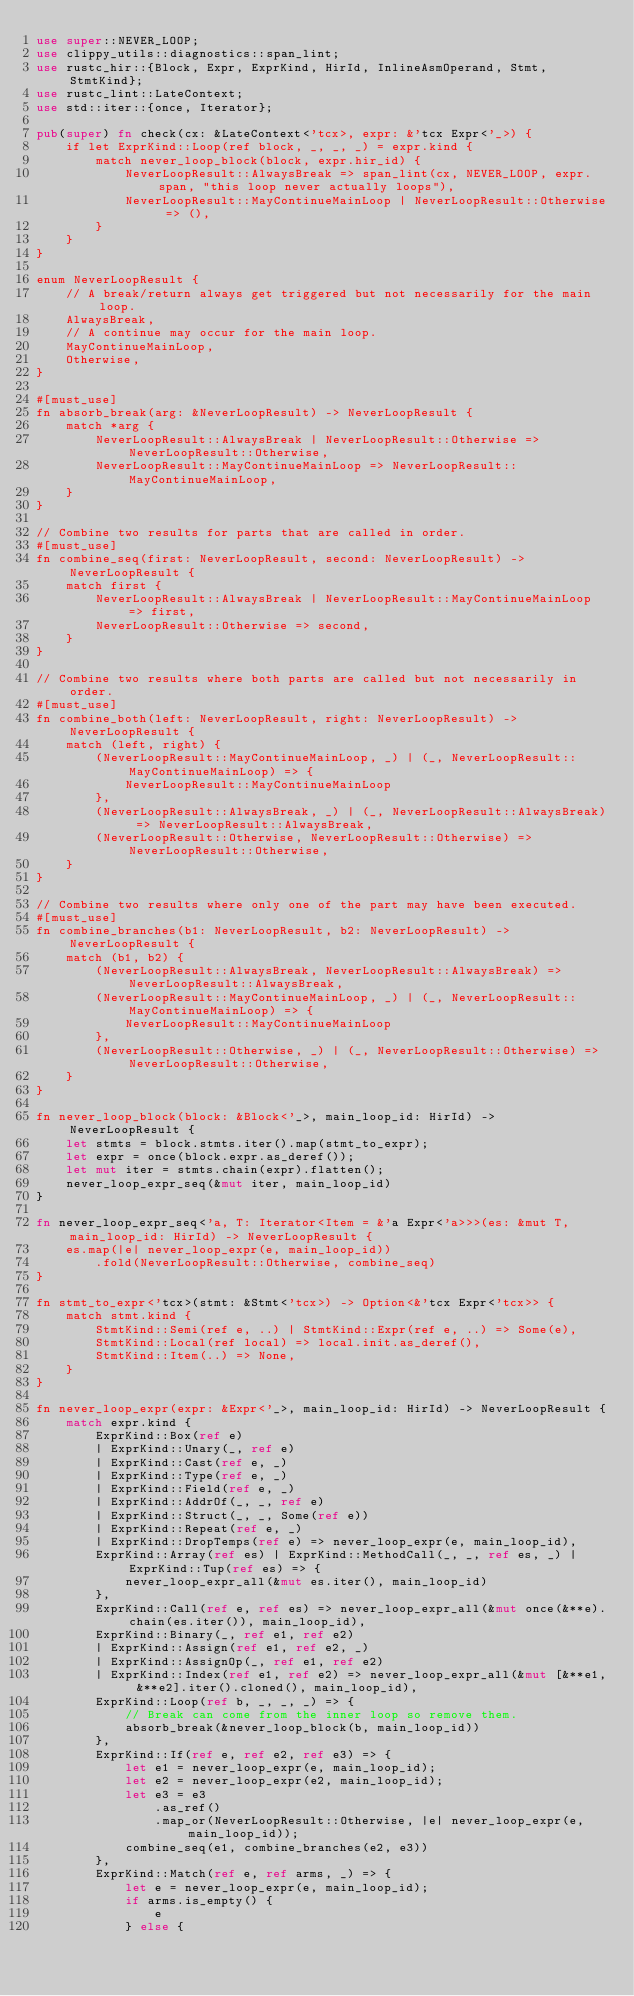Convert code to text. <code><loc_0><loc_0><loc_500><loc_500><_Rust_>use super::NEVER_LOOP;
use clippy_utils::diagnostics::span_lint;
use rustc_hir::{Block, Expr, ExprKind, HirId, InlineAsmOperand, Stmt, StmtKind};
use rustc_lint::LateContext;
use std::iter::{once, Iterator};

pub(super) fn check(cx: &LateContext<'tcx>, expr: &'tcx Expr<'_>) {
    if let ExprKind::Loop(ref block, _, _, _) = expr.kind {
        match never_loop_block(block, expr.hir_id) {
            NeverLoopResult::AlwaysBreak => span_lint(cx, NEVER_LOOP, expr.span, "this loop never actually loops"),
            NeverLoopResult::MayContinueMainLoop | NeverLoopResult::Otherwise => (),
        }
    }
}

enum NeverLoopResult {
    // A break/return always get triggered but not necessarily for the main loop.
    AlwaysBreak,
    // A continue may occur for the main loop.
    MayContinueMainLoop,
    Otherwise,
}

#[must_use]
fn absorb_break(arg: &NeverLoopResult) -> NeverLoopResult {
    match *arg {
        NeverLoopResult::AlwaysBreak | NeverLoopResult::Otherwise => NeverLoopResult::Otherwise,
        NeverLoopResult::MayContinueMainLoop => NeverLoopResult::MayContinueMainLoop,
    }
}

// Combine two results for parts that are called in order.
#[must_use]
fn combine_seq(first: NeverLoopResult, second: NeverLoopResult) -> NeverLoopResult {
    match first {
        NeverLoopResult::AlwaysBreak | NeverLoopResult::MayContinueMainLoop => first,
        NeverLoopResult::Otherwise => second,
    }
}

// Combine two results where both parts are called but not necessarily in order.
#[must_use]
fn combine_both(left: NeverLoopResult, right: NeverLoopResult) -> NeverLoopResult {
    match (left, right) {
        (NeverLoopResult::MayContinueMainLoop, _) | (_, NeverLoopResult::MayContinueMainLoop) => {
            NeverLoopResult::MayContinueMainLoop
        },
        (NeverLoopResult::AlwaysBreak, _) | (_, NeverLoopResult::AlwaysBreak) => NeverLoopResult::AlwaysBreak,
        (NeverLoopResult::Otherwise, NeverLoopResult::Otherwise) => NeverLoopResult::Otherwise,
    }
}

// Combine two results where only one of the part may have been executed.
#[must_use]
fn combine_branches(b1: NeverLoopResult, b2: NeverLoopResult) -> NeverLoopResult {
    match (b1, b2) {
        (NeverLoopResult::AlwaysBreak, NeverLoopResult::AlwaysBreak) => NeverLoopResult::AlwaysBreak,
        (NeverLoopResult::MayContinueMainLoop, _) | (_, NeverLoopResult::MayContinueMainLoop) => {
            NeverLoopResult::MayContinueMainLoop
        },
        (NeverLoopResult::Otherwise, _) | (_, NeverLoopResult::Otherwise) => NeverLoopResult::Otherwise,
    }
}

fn never_loop_block(block: &Block<'_>, main_loop_id: HirId) -> NeverLoopResult {
    let stmts = block.stmts.iter().map(stmt_to_expr);
    let expr = once(block.expr.as_deref());
    let mut iter = stmts.chain(expr).flatten();
    never_loop_expr_seq(&mut iter, main_loop_id)
}

fn never_loop_expr_seq<'a, T: Iterator<Item = &'a Expr<'a>>>(es: &mut T, main_loop_id: HirId) -> NeverLoopResult {
    es.map(|e| never_loop_expr(e, main_loop_id))
        .fold(NeverLoopResult::Otherwise, combine_seq)
}

fn stmt_to_expr<'tcx>(stmt: &Stmt<'tcx>) -> Option<&'tcx Expr<'tcx>> {
    match stmt.kind {
        StmtKind::Semi(ref e, ..) | StmtKind::Expr(ref e, ..) => Some(e),
        StmtKind::Local(ref local) => local.init.as_deref(),
        StmtKind::Item(..) => None,
    }
}

fn never_loop_expr(expr: &Expr<'_>, main_loop_id: HirId) -> NeverLoopResult {
    match expr.kind {
        ExprKind::Box(ref e)
        | ExprKind::Unary(_, ref e)
        | ExprKind::Cast(ref e, _)
        | ExprKind::Type(ref e, _)
        | ExprKind::Field(ref e, _)
        | ExprKind::AddrOf(_, _, ref e)
        | ExprKind::Struct(_, _, Some(ref e))
        | ExprKind::Repeat(ref e, _)
        | ExprKind::DropTemps(ref e) => never_loop_expr(e, main_loop_id),
        ExprKind::Array(ref es) | ExprKind::MethodCall(_, _, ref es, _) | ExprKind::Tup(ref es) => {
            never_loop_expr_all(&mut es.iter(), main_loop_id)
        },
        ExprKind::Call(ref e, ref es) => never_loop_expr_all(&mut once(&**e).chain(es.iter()), main_loop_id),
        ExprKind::Binary(_, ref e1, ref e2)
        | ExprKind::Assign(ref e1, ref e2, _)
        | ExprKind::AssignOp(_, ref e1, ref e2)
        | ExprKind::Index(ref e1, ref e2) => never_loop_expr_all(&mut [&**e1, &**e2].iter().cloned(), main_loop_id),
        ExprKind::Loop(ref b, _, _, _) => {
            // Break can come from the inner loop so remove them.
            absorb_break(&never_loop_block(b, main_loop_id))
        },
        ExprKind::If(ref e, ref e2, ref e3) => {
            let e1 = never_loop_expr(e, main_loop_id);
            let e2 = never_loop_expr(e2, main_loop_id);
            let e3 = e3
                .as_ref()
                .map_or(NeverLoopResult::Otherwise, |e| never_loop_expr(e, main_loop_id));
            combine_seq(e1, combine_branches(e2, e3))
        },
        ExprKind::Match(ref e, ref arms, _) => {
            let e = never_loop_expr(e, main_loop_id);
            if arms.is_empty() {
                e
            } else {</code> 